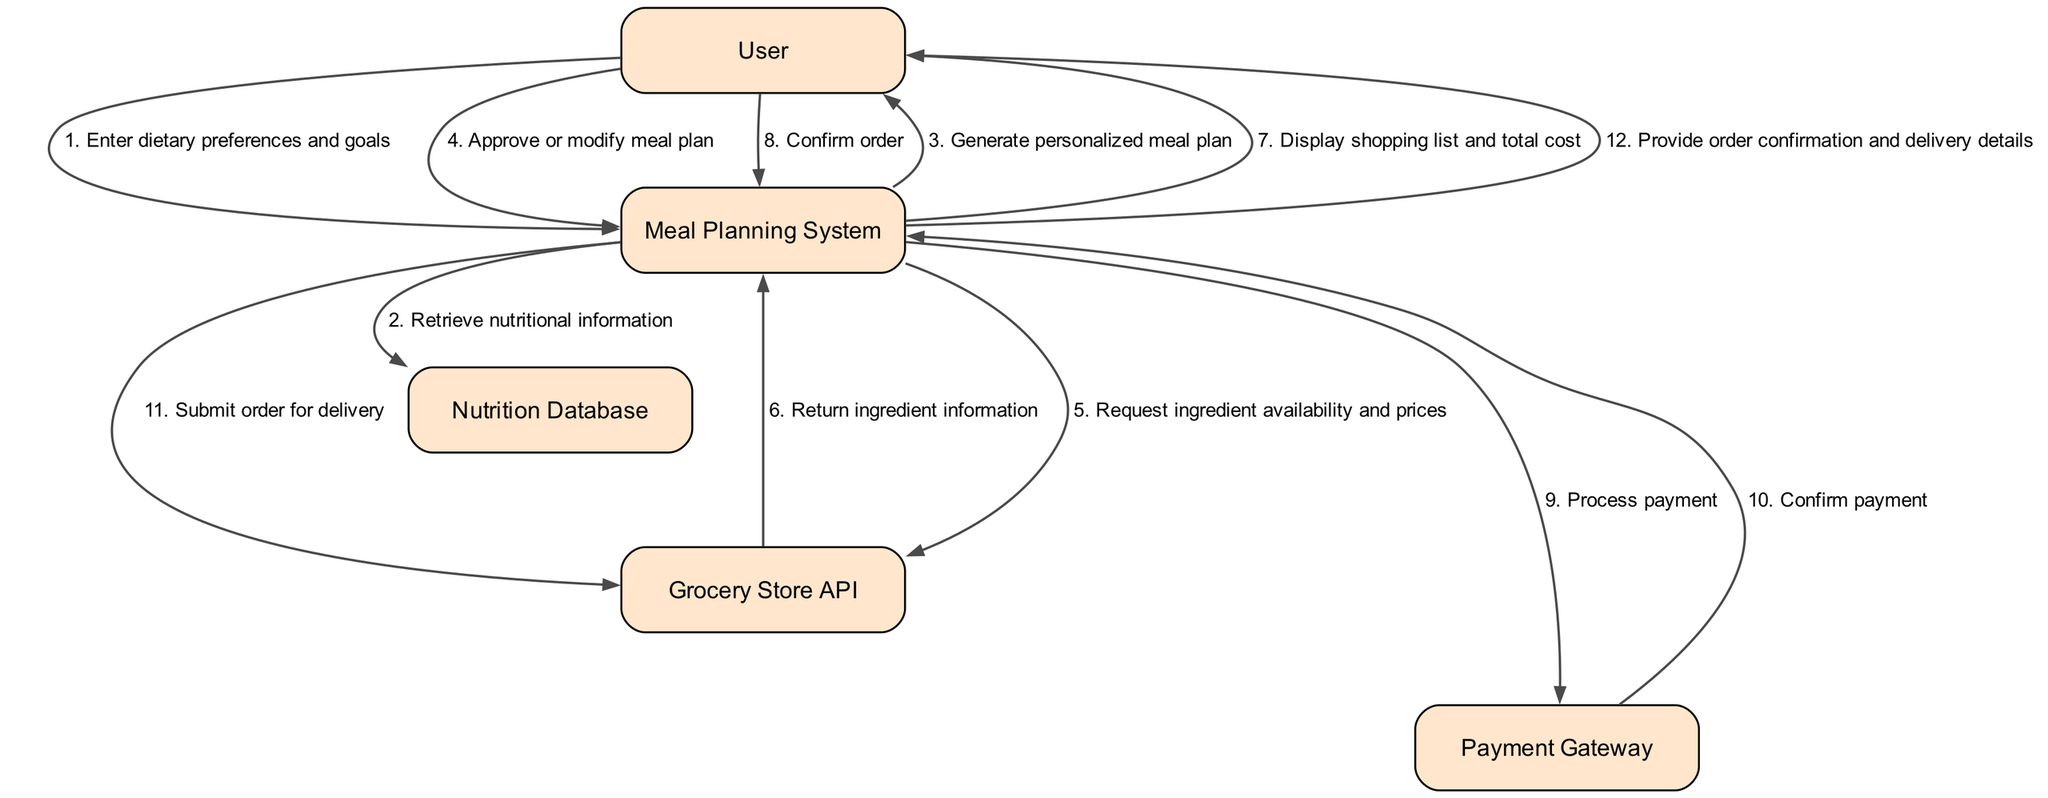What is the total number of nodes in the diagram? The nodes in the diagram are "User," "Meal Planning System," "Nutrition Database," "Grocery Store API," and "Payment Gateway." Counting these gives a total of 5 nodes.
Answer: 5 What action does the User take after generating the personalized meal plan? After the "Meal Planning System" generates the personalized meal plan, the next action from the "User" is to "Approve or modify meal plan."
Answer: Approve or modify meal plan Which actor provides the order confirmation and delivery details? The action "Provide order confirmation and delivery details" is sent from the "Meal Planning System" to "User," indicating the "User" receives this information.
Answer: User How many actions involve the Grocery Store API? The diagram shows two actions related to the "Grocery Store API" - "Request ingredient availability and prices" and "Return ingredient information," making it a total of 2 actions.
Answer: 2 What is the last action taken by the Meal Planning System? The last action in the sequence taken by the "Meal Planning System" is "Provide order confirmation and delivery details." This indicates it is the final step in the workflow.
Answer: Provide order confirmation and delivery details Which actor interacts with the Payment Gateway? The "Meal Planning System" interacts with the "Payment Gateway" to "Process payment," making it the only actor that does so in this workflow.
Answer: Meal Planning System What action follows the User confirming the order? After the "User" confirms the order, the next action taken by the "Meal Planning System" is to "Process payment," completing the transaction.
Answer: Process payment How many interactions does the User have with the Meal Planning System? The "User" has three interactions with the "Meal Planning System": "Enter dietary preferences and goals," "Approve or modify meal plan," and "Confirm order," totaling three interactions.
Answer: 3 Which action requires the Meal Planning System to access the Nutrition Database? The "Meal Planning System" requires the action "Retrieve nutritional information" to access the "Nutrition Database," indicating a retrieval process is essential in this step.
Answer: Retrieve nutritional information 